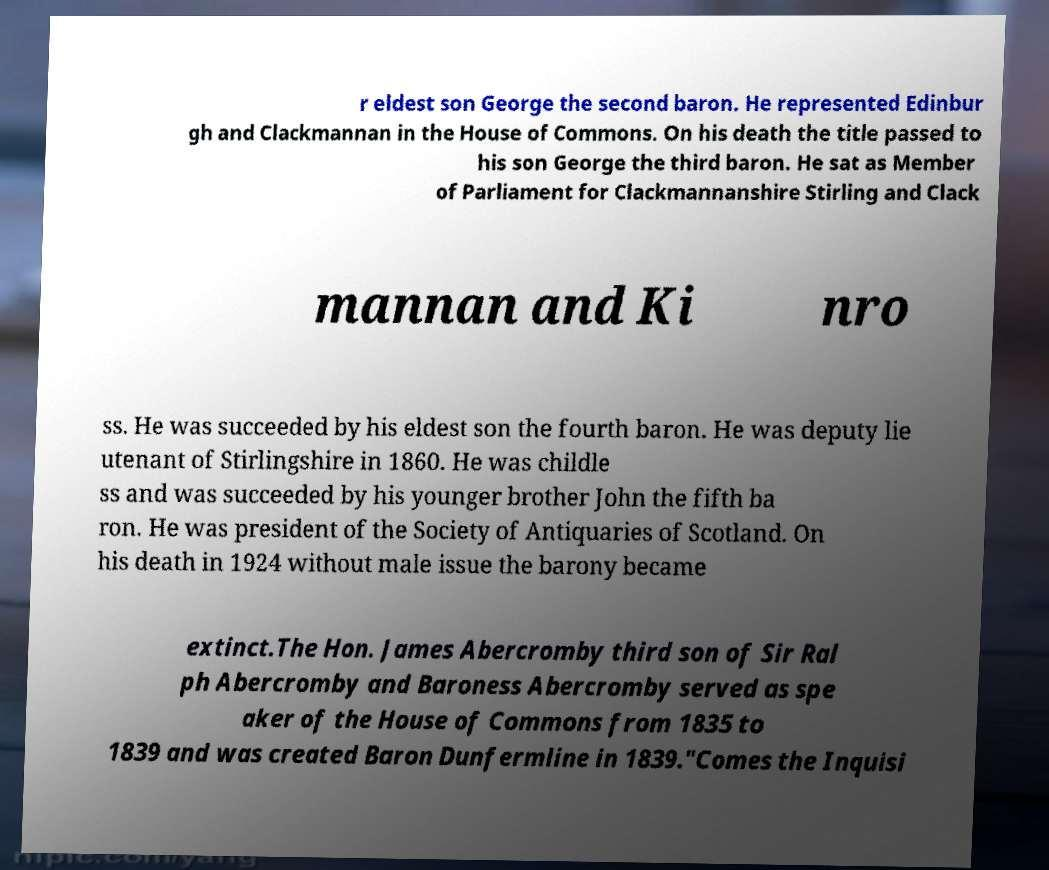Can you read and provide the text displayed in the image?This photo seems to have some interesting text. Can you extract and type it out for me? r eldest son George the second baron. He represented Edinbur gh and Clackmannan in the House of Commons. On his death the title passed to his son George the third baron. He sat as Member of Parliament for Clackmannanshire Stirling and Clack mannan and Ki nro ss. He was succeeded by his eldest son the fourth baron. He was deputy lie utenant of Stirlingshire in 1860. He was childle ss and was succeeded by his younger brother John the fifth ba ron. He was president of the Society of Antiquaries of Scotland. On his death in 1924 without male issue the barony became extinct.The Hon. James Abercromby third son of Sir Ral ph Abercromby and Baroness Abercromby served as spe aker of the House of Commons from 1835 to 1839 and was created Baron Dunfermline in 1839."Comes the Inquisi 